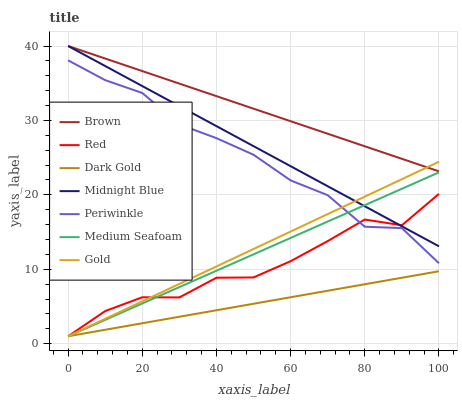Does Dark Gold have the minimum area under the curve?
Answer yes or no. Yes. Does Brown have the maximum area under the curve?
Answer yes or no. Yes. Does Midnight Blue have the minimum area under the curve?
Answer yes or no. No. Does Midnight Blue have the maximum area under the curve?
Answer yes or no. No. Is Dark Gold the smoothest?
Answer yes or no. Yes. Is Red the roughest?
Answer yes or no. Yes. Is Midnight Blue the smoothest?
Answer yes or no. No. Is Midnight Blue the roughest?
Answer yes or no. No. Does Midnight Blue have the lowest value?
Answer yes or no. No. Does Gold have the highest value?
Answer yes or no. No. Is Periwinkle less than Midnight Blue?
Answer yes or no. Yes. Is Brown greater than Dark Gold?
Answer yes or no. Yes. Does Periwinkle intersect Midnight Blue?
Answer yes or no. No. 